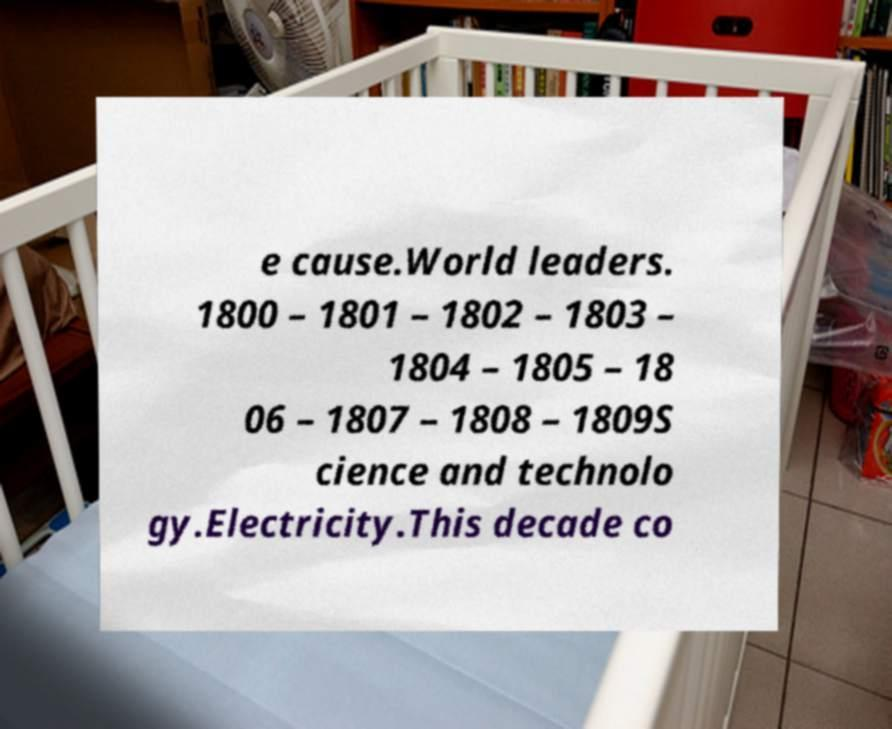There's text embedded in this image that I need extracted. Can you transcribe it verbatim? e cause.World leaders. 1800 – 1801 – 1802 – 1803 – 1804 – 1805 – 18 06 – 1807 – 1808 – 1809S cience and technolo gy.Electricity.This decade co 